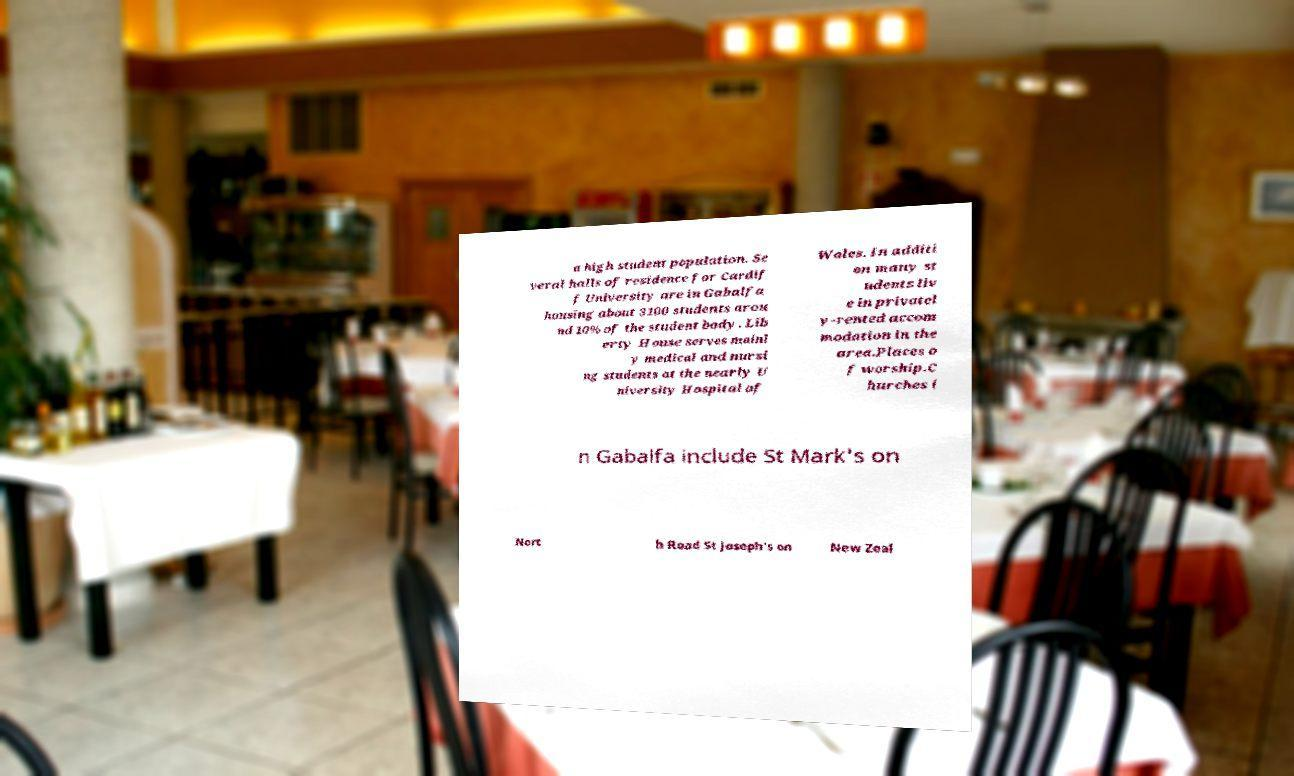What messages or text are displayed in this image? I need them in a readable, typed format. a high student population. Se veral halls of residence for Cardif f University are in Gabalfa housing about 3100 students arou nd 10% of the student body. Lib erty House serves mainl y medical and nursi ng students at the nearly U niversity Hospital of Wales. In additi on many st udents liv e in privatel y-rented accom modation in the area.Places o f worship.C hurches i n Gabalfa include St Mark's on Nort h Road St Joseph's on New Zeal 